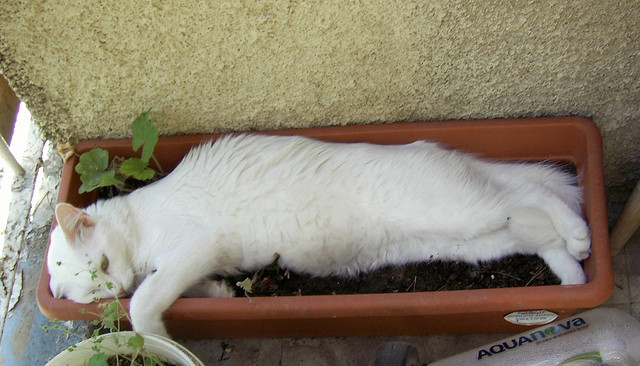Please transcribe the text information in this image. AQUAnova nova 